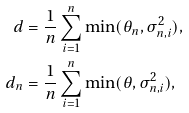<formula> <loc_0><loc_0><loc_500><loc_500>d & = \frac { 1 } { n } \sum _ { i = 1 } ^ { n } \min ( \theta _ { n } , \sigma _ { n , i } ^ { 2 } ) , \\ d _ { n } & = \frac { 1 } { n } \sum _ { i = 1 } ^ { n } \min ( \theta , \sigma _ { n , i } ^ { 2 } ) ,</formula> 